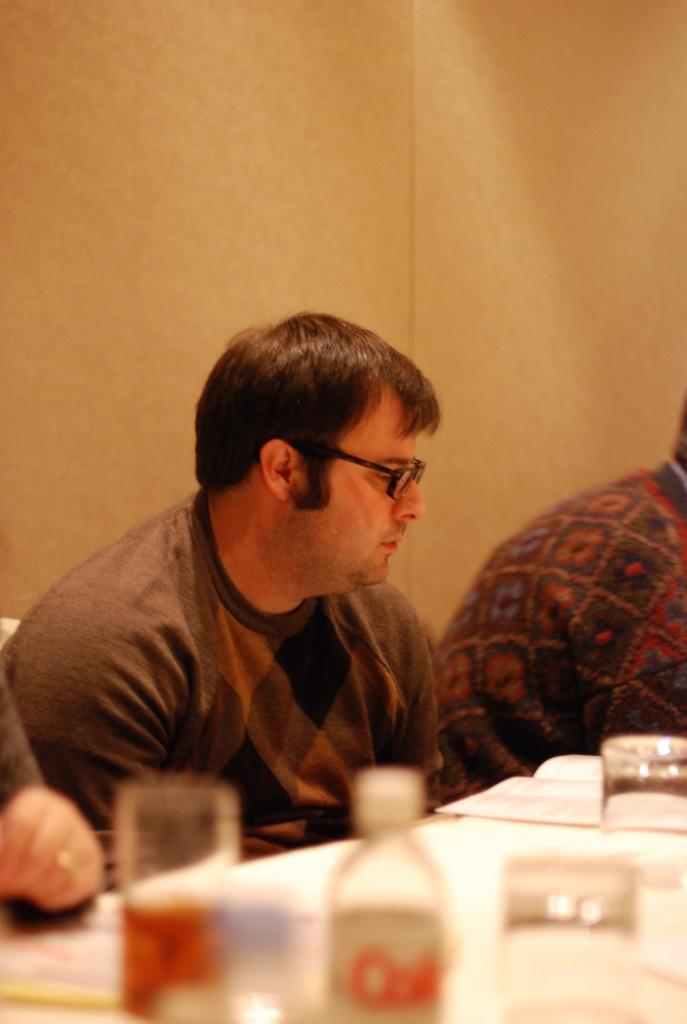How many people are in the image? There are three people in the image. What are the people doing in the image? The people are sitting on chairs. What is in front of the people? There is a table in front of the people. What can be seen on the table? There are glasses, a bottle, and papers on the table. What is behind the people? A: There is a wall behind the people. What type of tooth is visible on the table in the image? There is no tooth present on the table in the image. What color is the silverware on the table in the image? There is no silverware mentioned in the image, only glasses, a bottle, and papers on the table. 